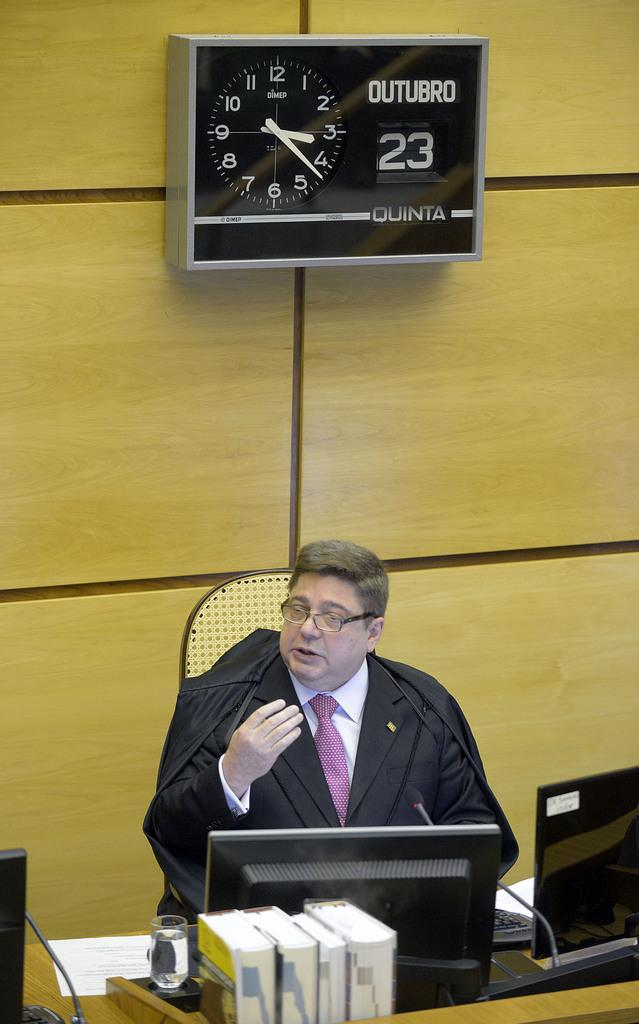<image>
Relay a brief, clear account of the picture shown. A man in a black robe sitting under a QUINTA clock. 